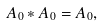<formula> <loc_0><loc_0><loc_500><loc_500>A _ { 0 } \ast A _ { 0 } = A _ { 0 } ,</formula> 